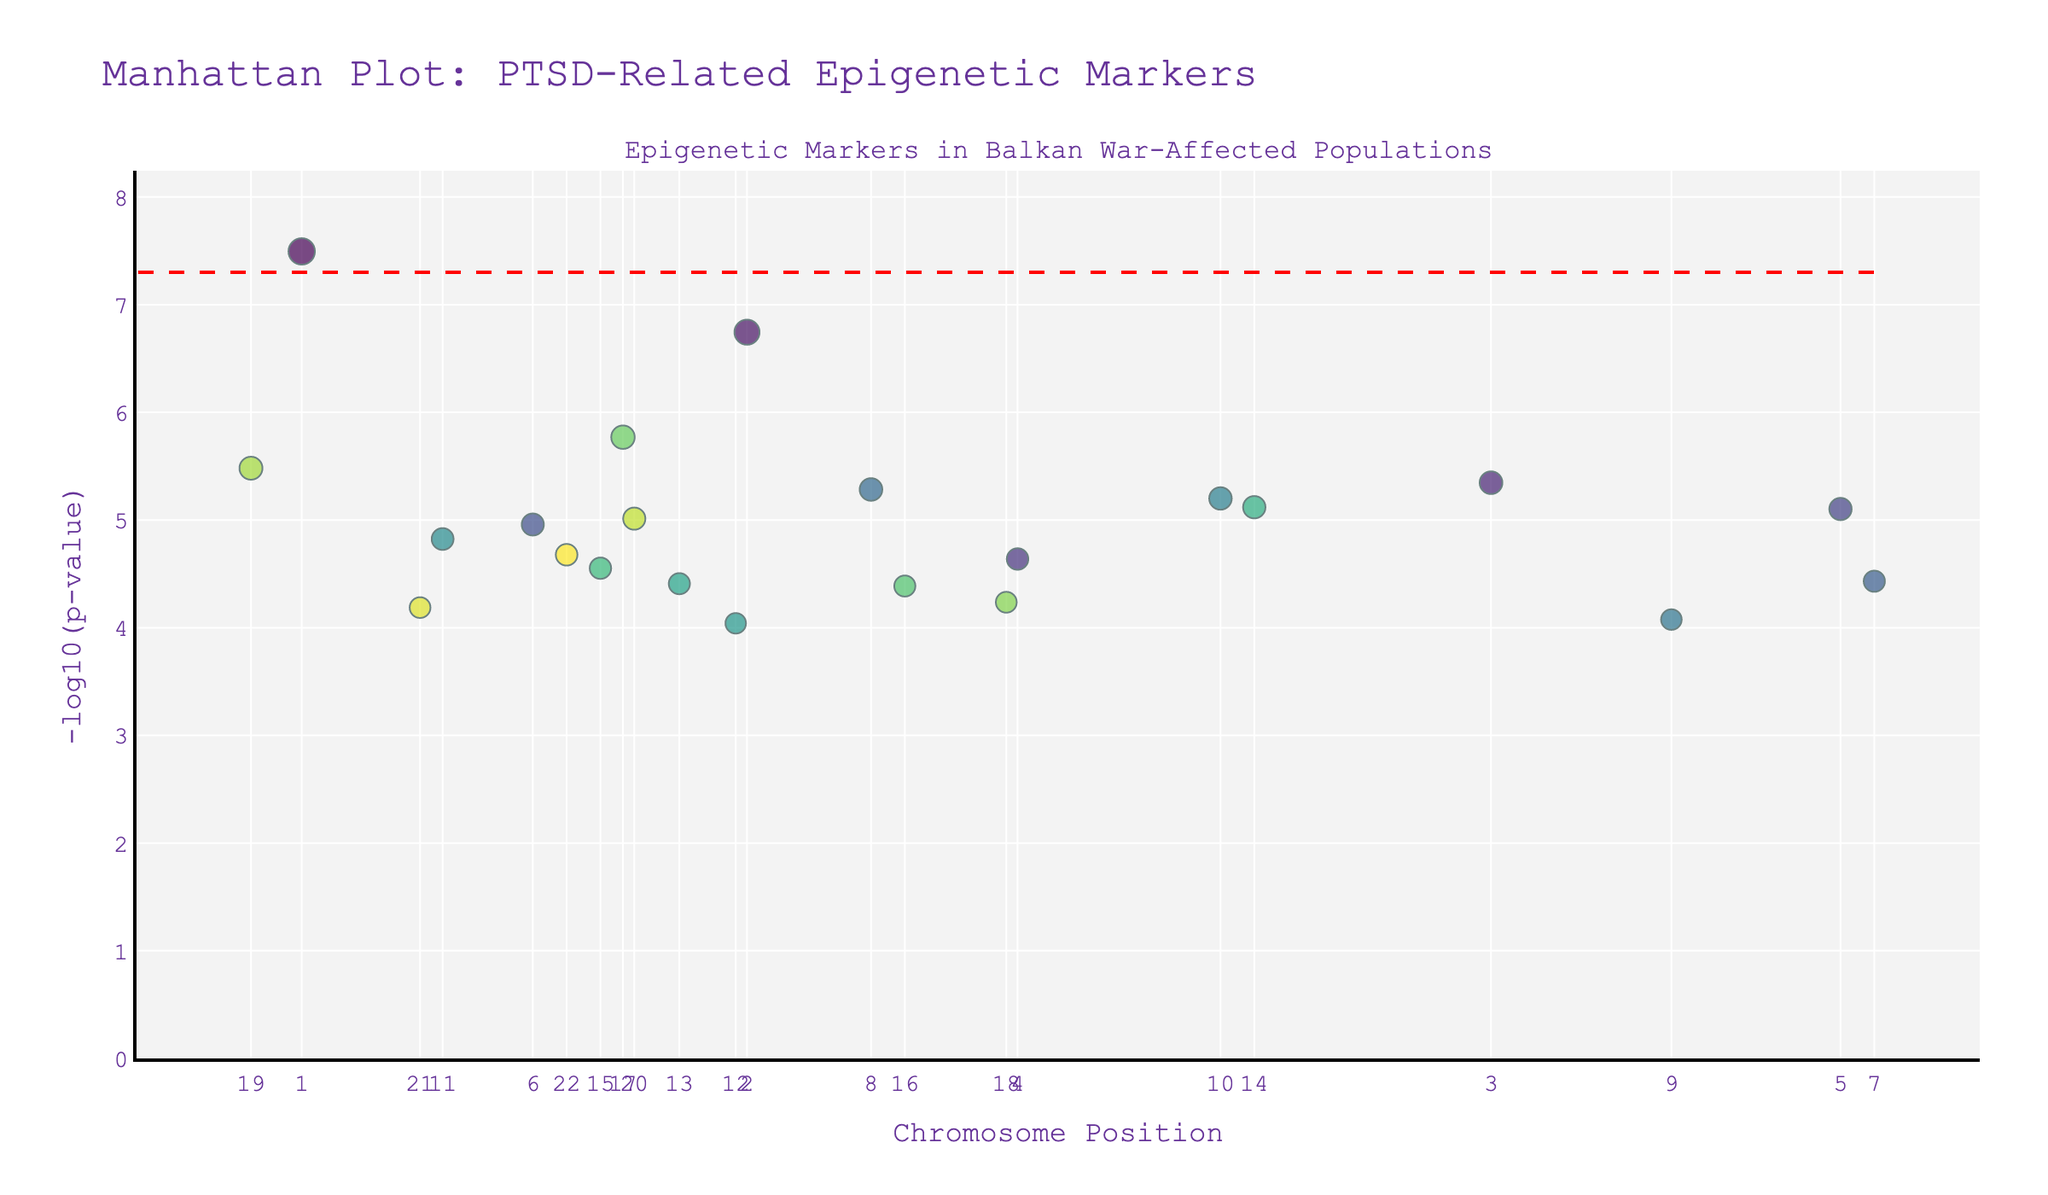What is the title of the plot? The title is found at the top of the plot and it reads "Manhattan Plot: PTSD-Related Epigenetic Markers".
Answer: Manhattan Plot: PTSD-Related Epigenetic Markers What are the axes titles for the Manhattan plot? The x-axis title is "Chromosome Position" which is found along the bottom of the plot, and the y-axis title is "-log10(p-value)" which is found along the left side of the plot.
Answer: Chromosome Position and -log10(p-value) Which gene has the most significant p-value according to the plot, and how do you know? The significance is denoted by -log10(p-value); the higher the value, the more significant the p-value. The gene FKBP5 on Chromosome 1 has the most significant p-value with the highest -log10(p-value).
Answer: FKBP5 How is the size of a data point determined in this plot, and what does it represent? The size of each data point is based on the p-value significance, calculated as "8 - log10(p-value)". Larger sizes correspond to more significant p-values (smaller p-values). This means genes with smaller p-values (more significant) have larger marker sizes.
Answer: Based on the significance of p-value Among the genes with significant markers, which two genes have very similar -log10(p-values)? By comparing the y-axis values, ADCYAP1R1 (on Chromosome 2) and CACNA1C (on Chromosome 19) have very similar -log10(p-values), both close to 7.75.
Answer: ADCYAP1R1 and CACNA1C What is the p-value threshold indicated by the horizontal red dashed line in the plot? The red dashed line represents the traditional genome-wide significance threshold which is at a p-value of 5e-8, and its -log10 value is approximately 7.3.
Answer: 5e-8 How many genes have markers above the red dashed line? Count the number of data points that lie above the horizontal red dashed line representing -log10(5e-8). In the given plot, only FKBP5 is above this threshold.
Answer: 1 gene Which chromosome contains the gene COMT, and how can you identify it from the plot? COMT appears as a marker point on Chromosomes 6 and 22. The hover information indicates the gene names which can help identify where they are located.
Answer: Chromosomes 6 and 22 Comparing the genes BDNF and MAOA, which one has a smaller p-value? A smaller p-value corresponds to a higher -log10(p-value). MAOA (on Chromosome 17) is higher on the y-axis than BDNF (on Chromosome 11), indicating MAOA has a smaller p-value and is more significant.
Answer: MAOA 